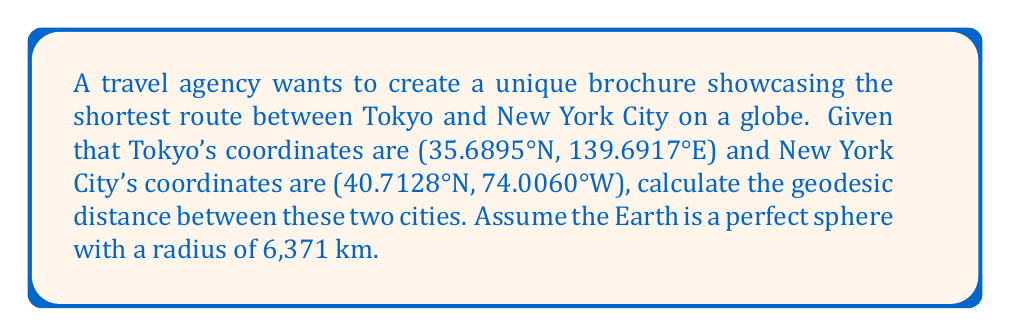Help me with this question. To calculate the geodesic distance between two points on a sphere, we use the Great Circle Distance formula:

1) Convert the latitude and longitude to radians:
   Tokyo: $\phi_1 = 35.6895° \times \frac{\pi}{180} = 0.6228$ rad
           $\lambda_1 = 139.6917° \times \frac{\pi}{180} = 2.4379$ rad
   NYC:   $\phi_2 = 40.7128° \times \frac{\pi}{180} = 0.7104$ rad
           $\lambda_2 = -74.0060° \times \frac{\pi}{180} = -1.2915$ rad

2) Calculate the central angle $\Delta\sigma$ using the Haversine formula:
   $$\Delta\sigma = 2 \arcsin\left(\sqrt{\sin^2\left(\frac{\phi_2-\phi_1}{2}\right) + \cos\phi_1 \cos\phi_2 \sin^2\left(\frac{\lambda_2-\lambda_1}{2}\right)}\right)$$

3) Substitute the values:
   $$\Delta\sigma = 2 \arcsin\left(\sqrt{\sin^2\left(\frac{0.7104-0.6228}{2}\right) + \cos(0.6228) \cos(0.7104) \sin^2\left(\frac{-1.2915-2.4379}{2}\right)}\right)$$

4) Evaluate:
   $$\Delta\sigma = 2 \arcsin(\sqrt{0.0019 + 0.7456 \times 0.7458}) = 1.9635$$

5) Calculate the geodesic distance $d$ using the formula:
   $$d = R \times \Delta\sigma$$
   Where $R$ is the radius of the Earth (6,371 km)

6) Substitute and calculate:
   $$d = 6371 \times 1.9635 = 12,506.7 \text{ km}$$

The geodesic distance between Tokyo and New York City is approximately 12,506.7 km.
Answer: 12,506.7 km 